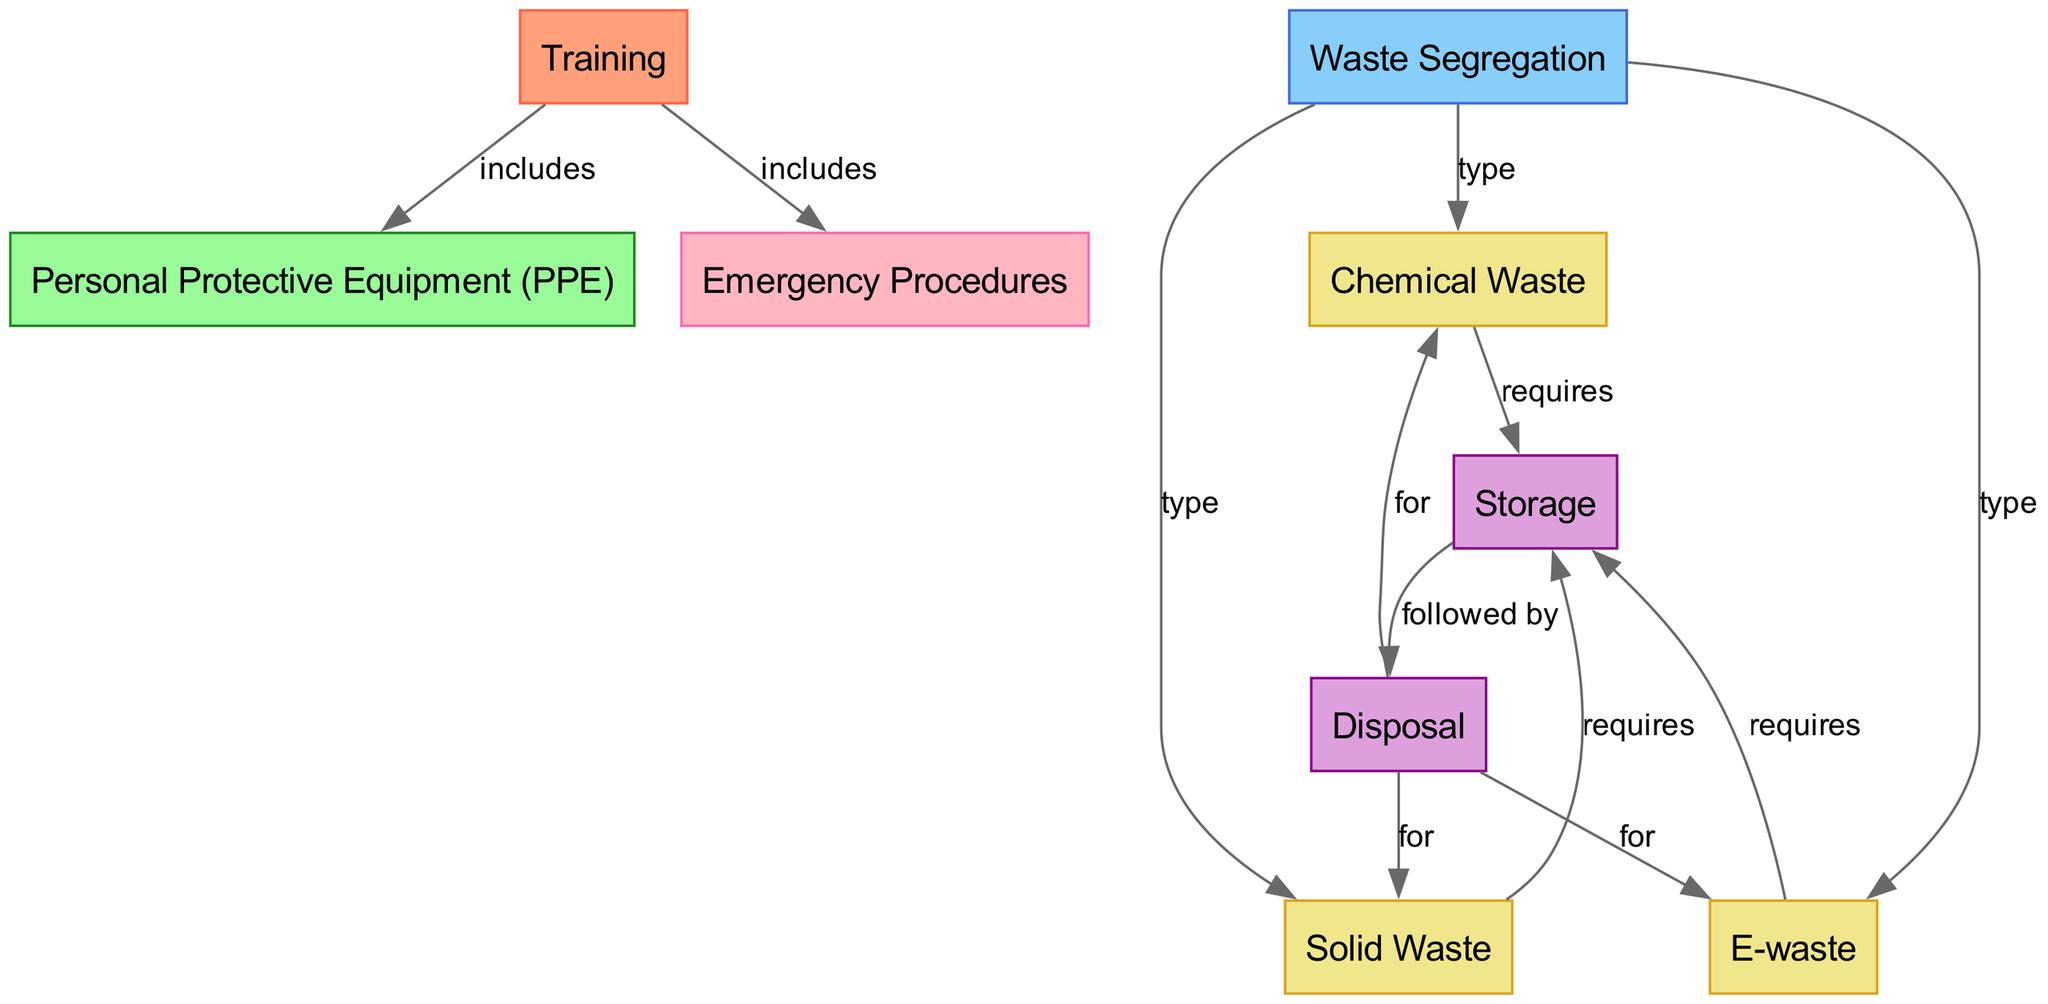What is the first node in the diagram? The first node in the diagram is "Training," which serves as the starting point for understanding the safe handling and disposal of industrial waste.
Answer: Training How many types of waste are shown in the diagram? The diagram displays three types of waste: Chemical Waste, Solid Waste, and E-waste. This is deduced from the connections under the Waste Segregation node.
Answer: 3 What does the Training node include? The Training node includes both Personal Protective Equipment (PPE) and Emergency Procedures, which are directly linked as components of the training process.
Answer: Personal Protective Equipment (PPE), Emergency Procedures Which node requires all types of waste before disposal? The Storage node is the one that requires Chemical Waste, Solid Waste, and E-waste before they can be disposed of. The connections show that all three types require proper storage.
Answer: Storage What are the types of waste that are followed by disposal? The types of waste that are followed by disposal include Chemical Waste, Solid Waste, and E-waste, as indicated by the connections showing the direction from Disposal for these waste types.
Answer: Chemical Waste, Solid Waste, E-waste Which node is directly linked to Personal Protective Equipment (PPE)? The node directly linked to Personal Protective Equipment (PPE) is the Training node, indicating that PPE is included in the training process.
Answer: Training How do the edges represent relationships between the nodes? The edges in the diagram represent different types of relationships, such as inclusion (e.g., Training includes PPE) and requirements (e.g., Chemical Waste requires Storage), illustrating how each node interacts within the process of waste handling and disposal.
Answer: Various relationships depicted What is the relationship between Waste Segregation and the types of waste? Waste Segregation directly categorizes the types of waste as it shows the relationships connecting to Chemical Waste, Solid Waste, and E-waste, indicating the categorization is based on the type of waste.
Answer: Type How many edges are there in the diagram? The diagram contains ten edges connecting the nodes, illustrating the various relationships and processes involved in the handling of industrial waste.
Answer: 10 